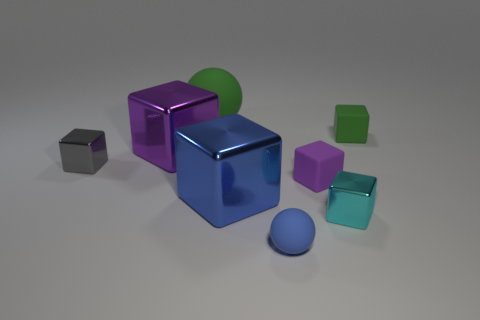The purple shiny thing that is the same shape as the tiny cyan thing is what size?
Ensure brevity in your answer.  Large. There is a matte block in front of the small shiny cube that is behind the cyan cube; what number of shiny cubes are left of it?
Your response must be concise. 3. Is the number of rubber blocks behind the small cyan shiny thing the same as the number of large metal things?
Your answer should be very brief. Yes. How many cylinders are cyan things or tiny green objects?
Provide a succinct answer. 0. Are there the same number of big blocks that are in front of the small blue thing and gray metal cubes in front of the tiny purple thing?
Provide a succinct answer. Yes. The big rubber ball has what color?
Offer a terse response. Green. How many objects are either big objects in front of the small green block or small matte things?
Your answer should be compact. 5. There is a rubber block in front of the green block; is it the same size as the rubber sphere that is behind the purple shiny cube?
Provide a short and direct response. No. What number of things are either matte things that are behind the cyan metallic object or balls on the left side of the tiny blue object?
Offer a terse response. 3. Is the material of the large green sphere the same as the tiny cube behind the gray object?
Provide a succinct answer. Yes. 